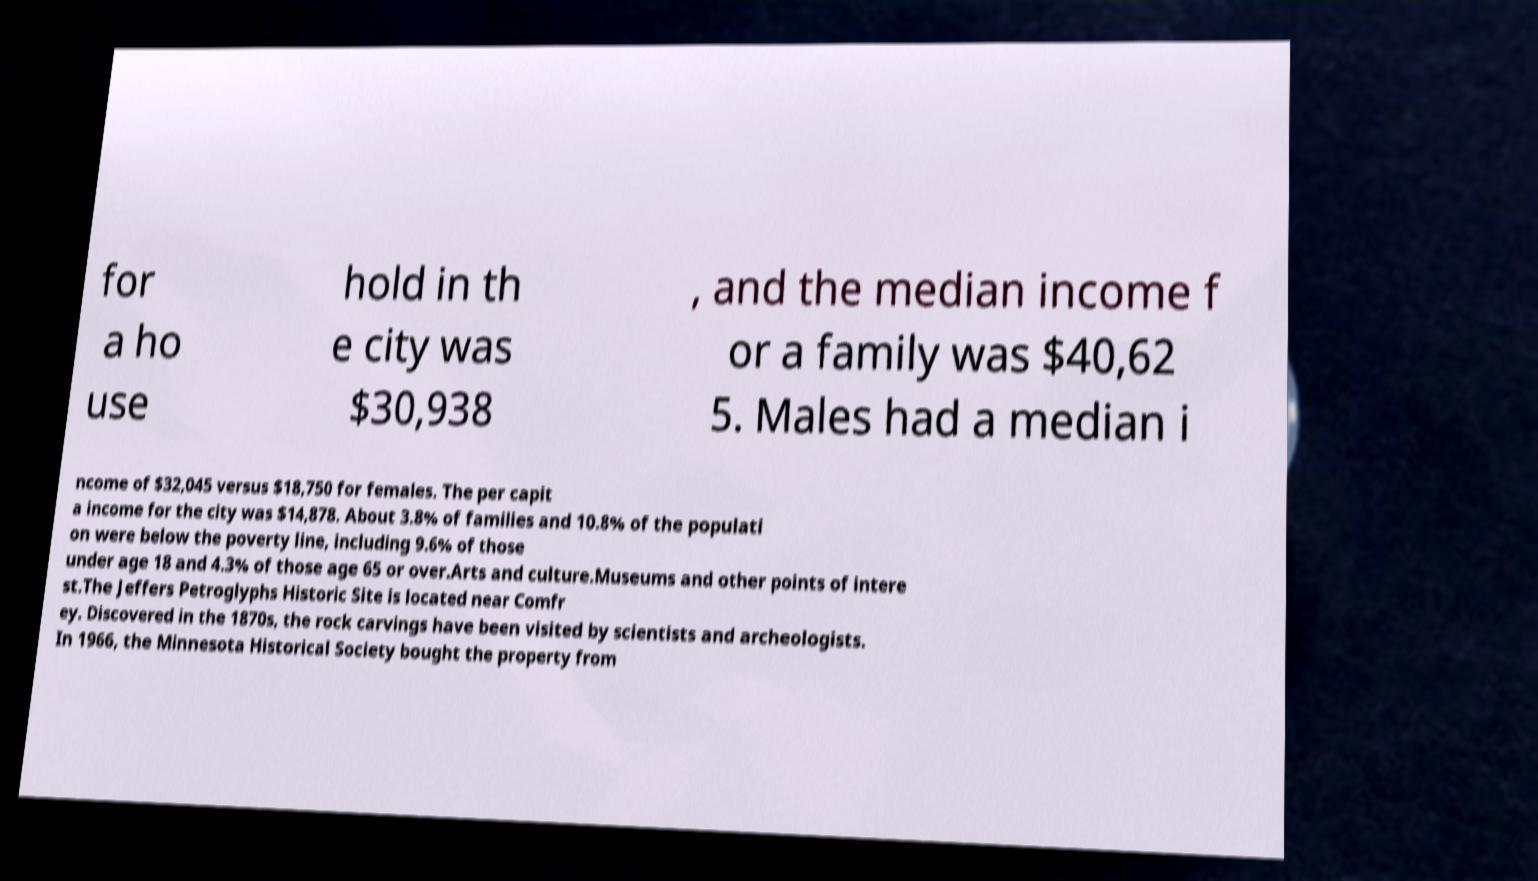Please identify and transcribe the text found in this image. for a ho use hold in th e city was $30,938 , and the median income f or a family was $40,62 5. Males had a median i ncome of $32,045 versus $18,750 for females. The per capit a income for the city was $14,878. About 3.8% of families and 10.8% of the populati on were below the poverty line, including 9.6% of those under age 18 and 4.3% of those age 65 or over.Arts and culture.Museums and other points of intere st.The Jeffers Petroglyphs Historic Site is located near Comfr ey. Discovered in the 1870s, the rock carvings have been visited by scientists and archeologists. In 1966, the Minnesota Historical Society bought the property from 